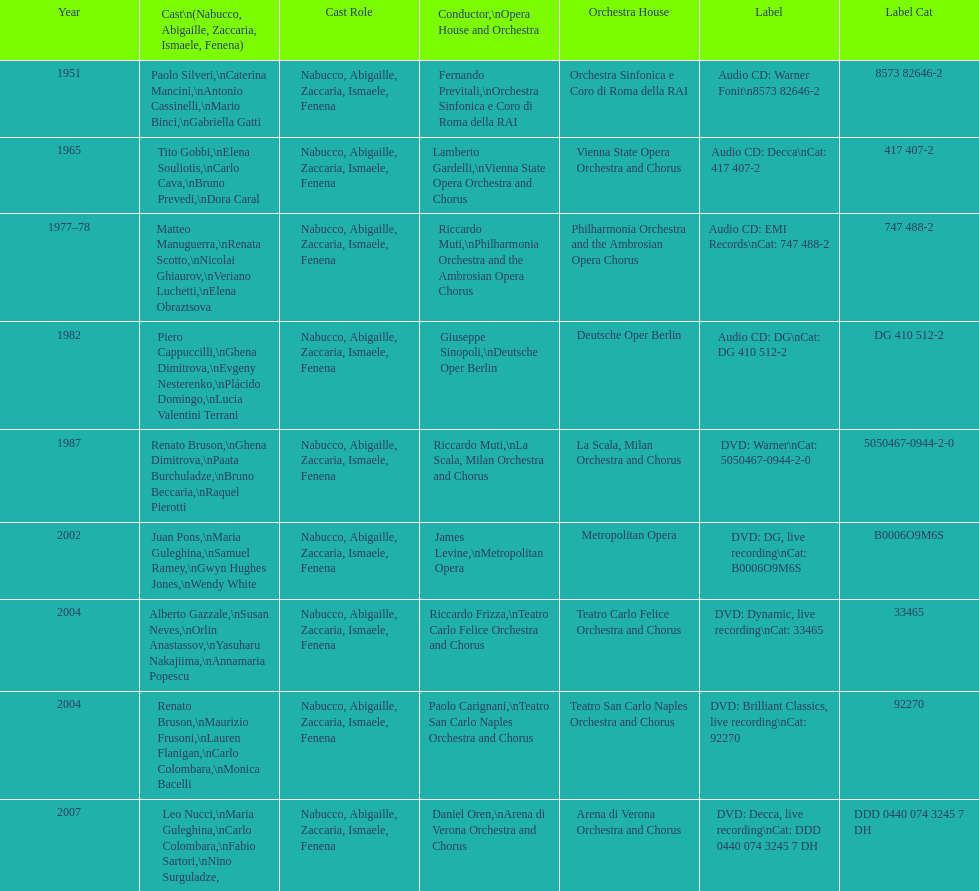When was the recording of nabucco made in the metropolitan opera? 2002. 